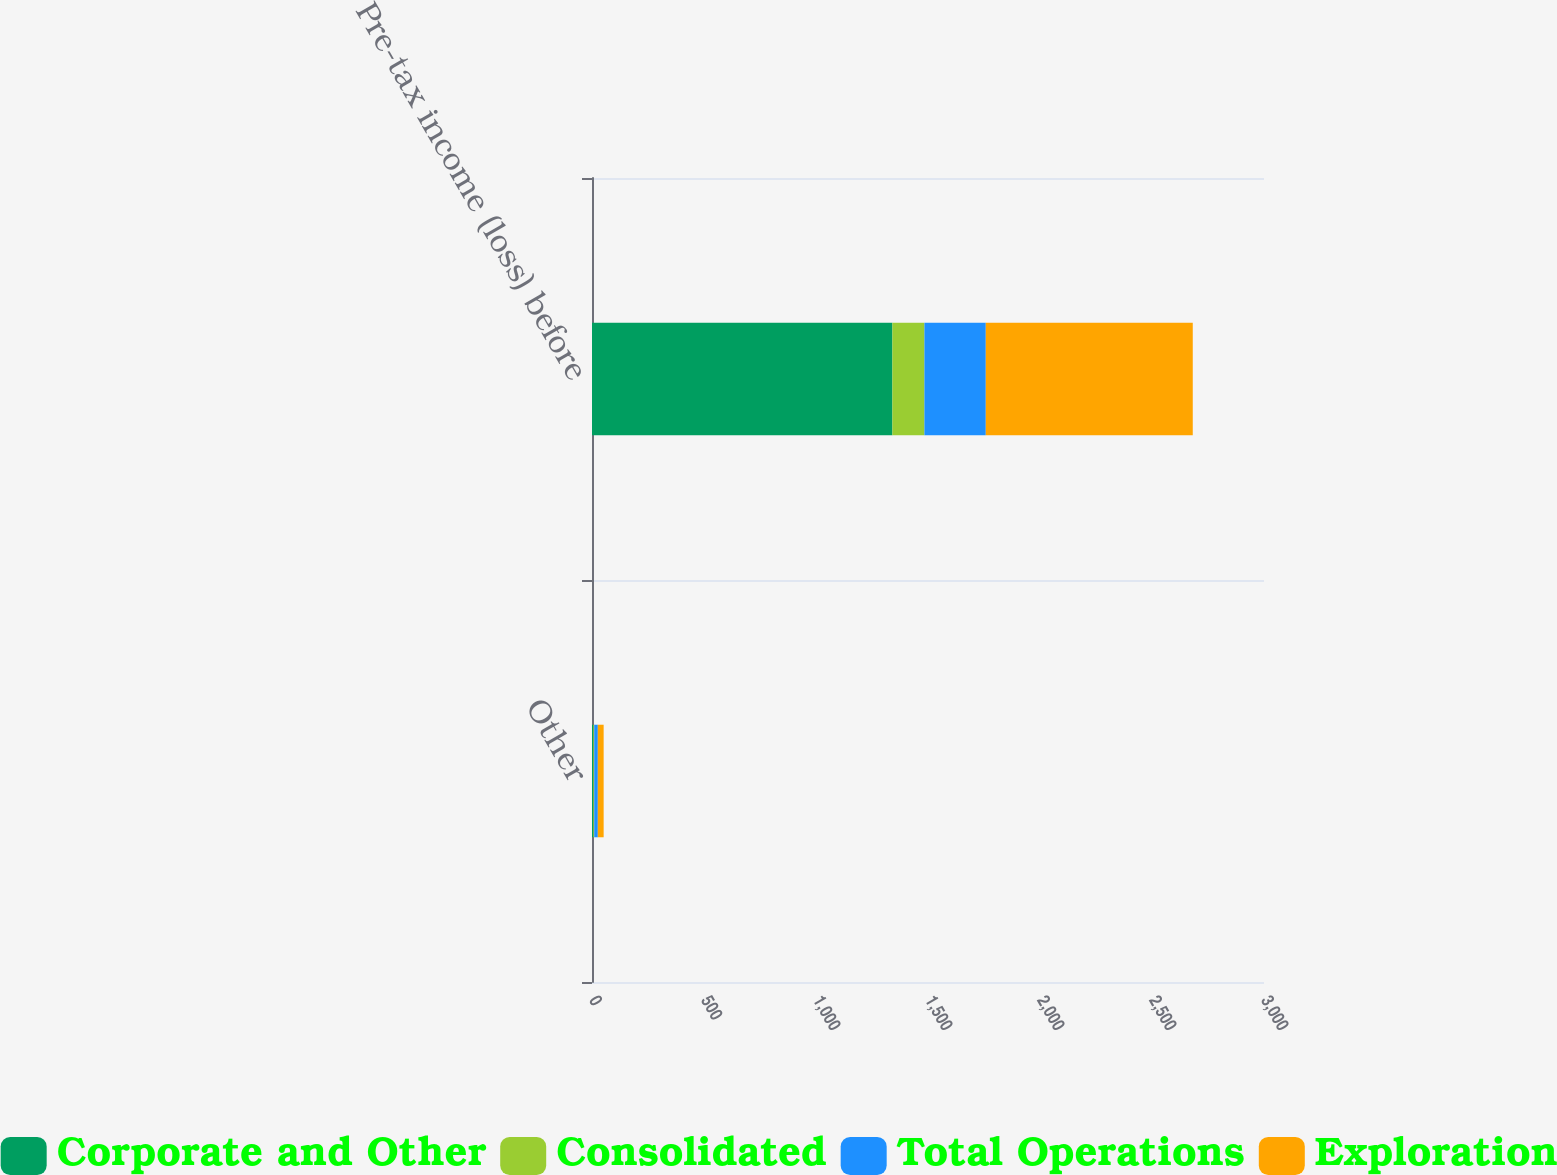Convert chart to OTSL. <chart><loc_0><loc_0><loc_500><loc_500><stacked_bar_chart><ecel><fcel>Other<fcel>Pre-tax income (loss) before<nl><fcel>Corporate and Other<fcel>6<fcel>1341<nl><fcel>Consolidated<fcel>4<fcel>143<nl><fcel>Total Operations<fcel>16<fcel>274<nl><fcel>Exploration<fcel>26<fcel>924<nl></chart> 